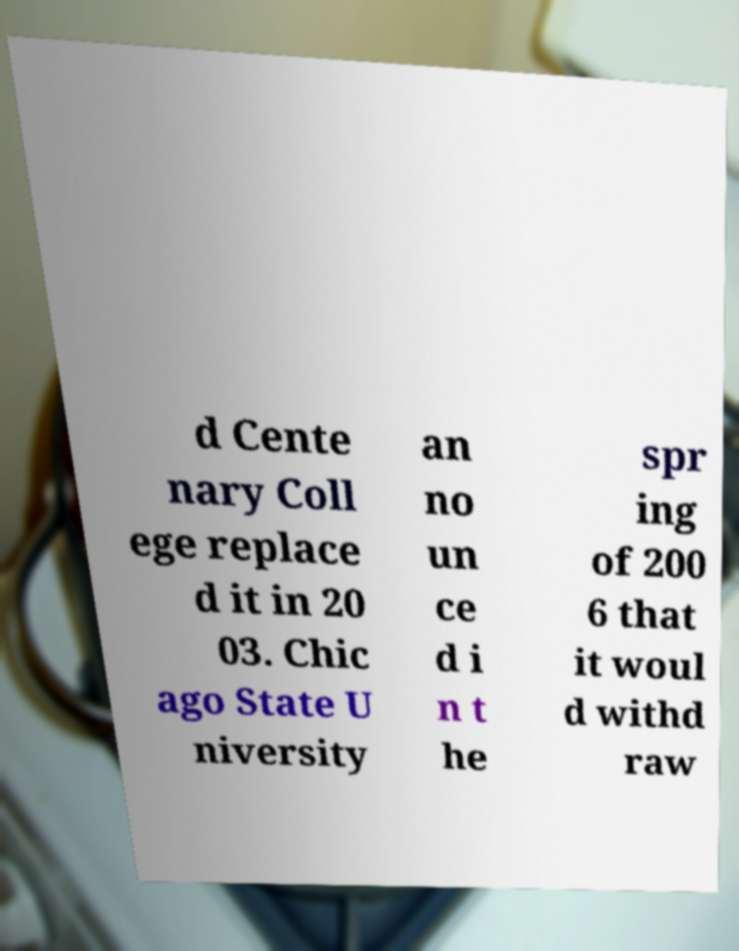What messages or text are displayed in this image? I need them in a readable, typed format. d Cente nary Coll ege replace d it in 20 03. Chic ago State U niversity an no un ce d i n t he spr ing of 200 6 that it woul d withd raw 